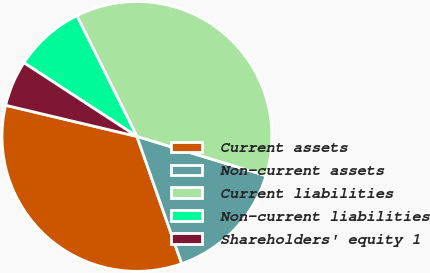Convert chart. <chart><loc_0><loc_0><loc_500><loc_500><pie_chart><fcel>Current assets<fcel>Non-current assets<fcel>Current liabilities<fcel>Non-current liabilities<fcel>Shareholders' equity 1<nl><fcel>34.09%<fcel>14.92%<fcel>37.05%<fcel>8.45%<fcel>5.49%<nl></chart> 